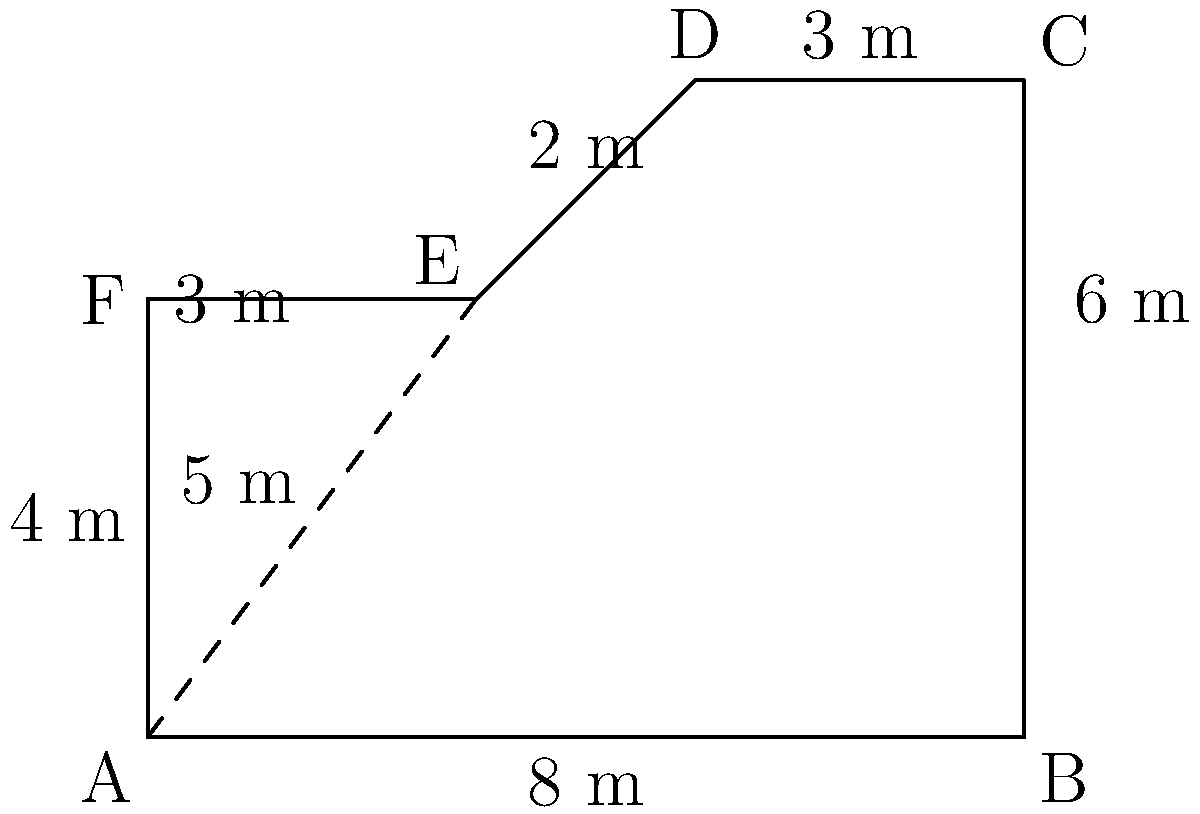Your aunt has designed an irregularly shaped room for an art gallery. The room has angled walls as shown in the diagram. Calculate the total area of the room in square meters. Round your answer to the nearest whole number. To calculate the area of this irregularly shaped room, we can divide it into simpler shapes and sum their areas:

1. Rectangle ABCF:
   Area = 8 m × 4 m = 32 m²

2. Triangle AEF:
   Base = 3 m, Height = 4 m
   Area = $\frac{1}{2} \times 3 \text{ m} \times 4 \text{ m} = 6$ m²

3. Trapezoid CDEF:
   Parallel sides: 3 m and 5 m, Height = 2 m
   Area = $\frac{1}{2}(3 \text{ m} + 5 \text{ m}) \times 2 \text{ m} = 8$ m²

Total Area = 32 m² + 6 m² + 8 m² = 46 m²

Rounding to the nearest whole number: 46 m²
Answer: 46 m² 